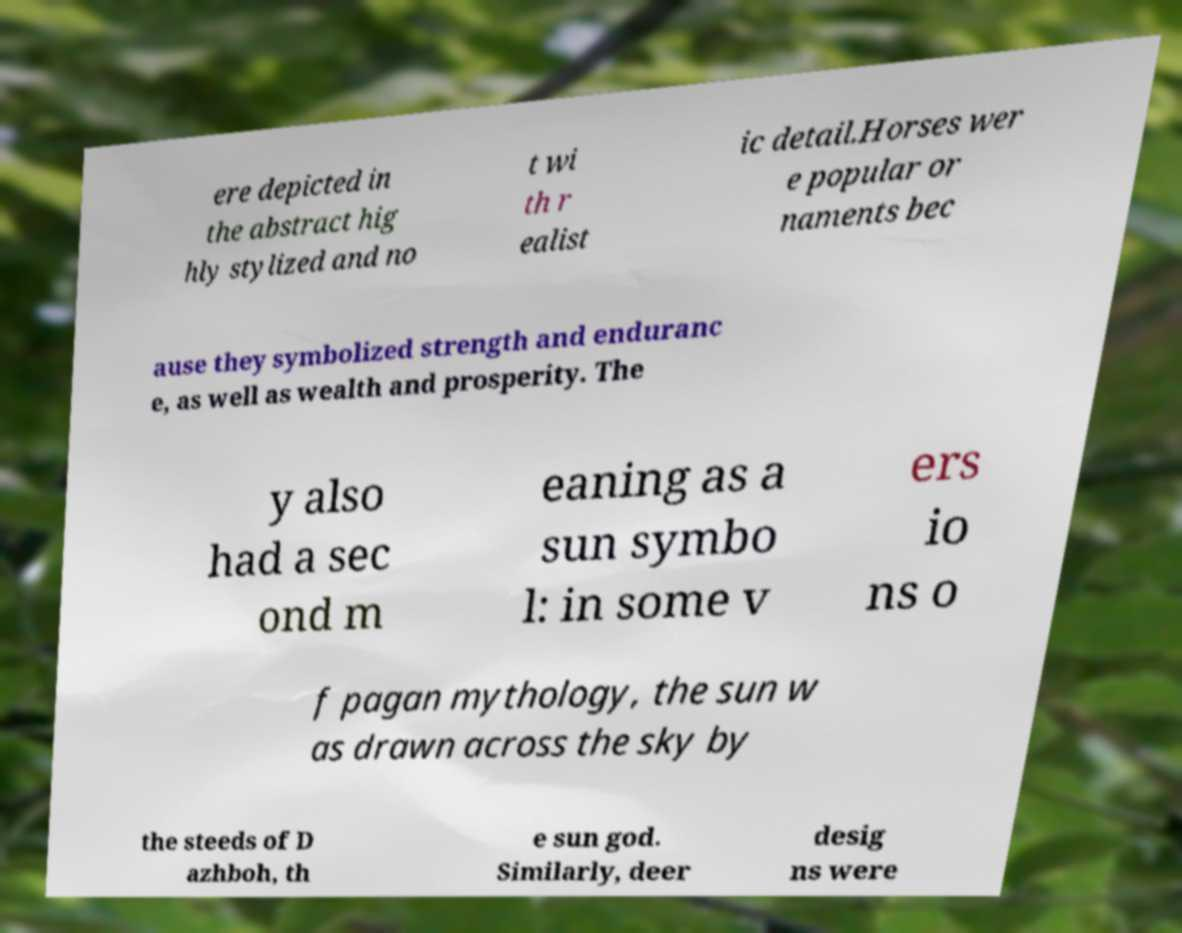Can you read and provide the text displayed in the image?This photo seems to have some interesting text. Can you extract and type it out for me? ere depicted in the abstract hig hly stylized and no t wi th r ealist ic detail.Horses wer e popular or naments bec ause they symbolized strength and enduranc e, as well as wealth and prosperity. The y also had a sec ond m eaning as a sun symbo l: in some v ers io ns o f pagan mythology, the sun w as drawn across the sky by the steeds of D azhboh, th e sun god. Similarly, deer desig ns were 